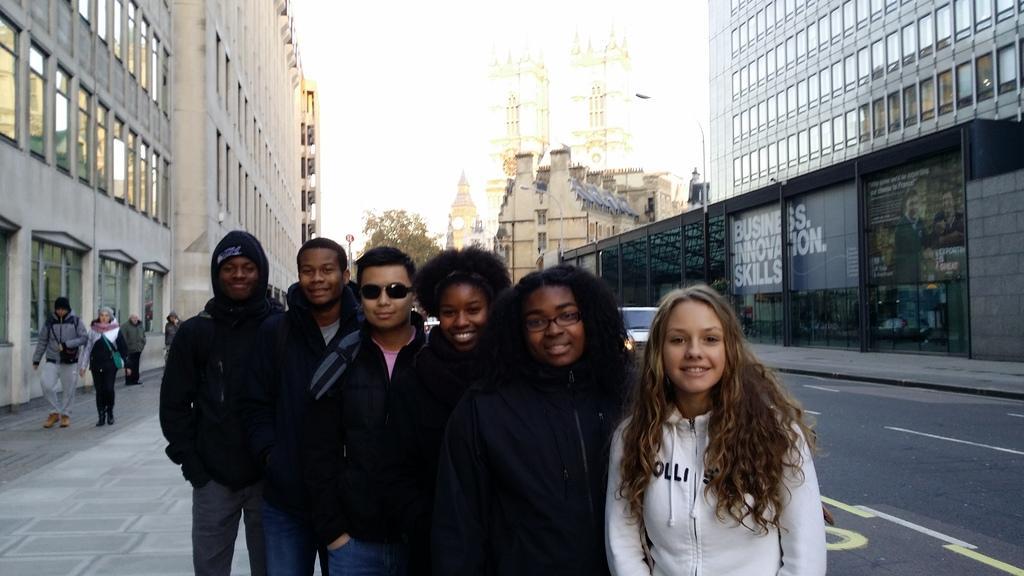Please provide a concise description of this image. There are persons in different color dresses, smiling and standing, near a footpath and a road, on which, there is a vehicle. On the left side, there is a footpath, on which, there are persons walking, in building, which is having glass windows. On the right side, there is a footpath, near a building which is having glass windows. In the background, there are buildings, trees and there is sky. 